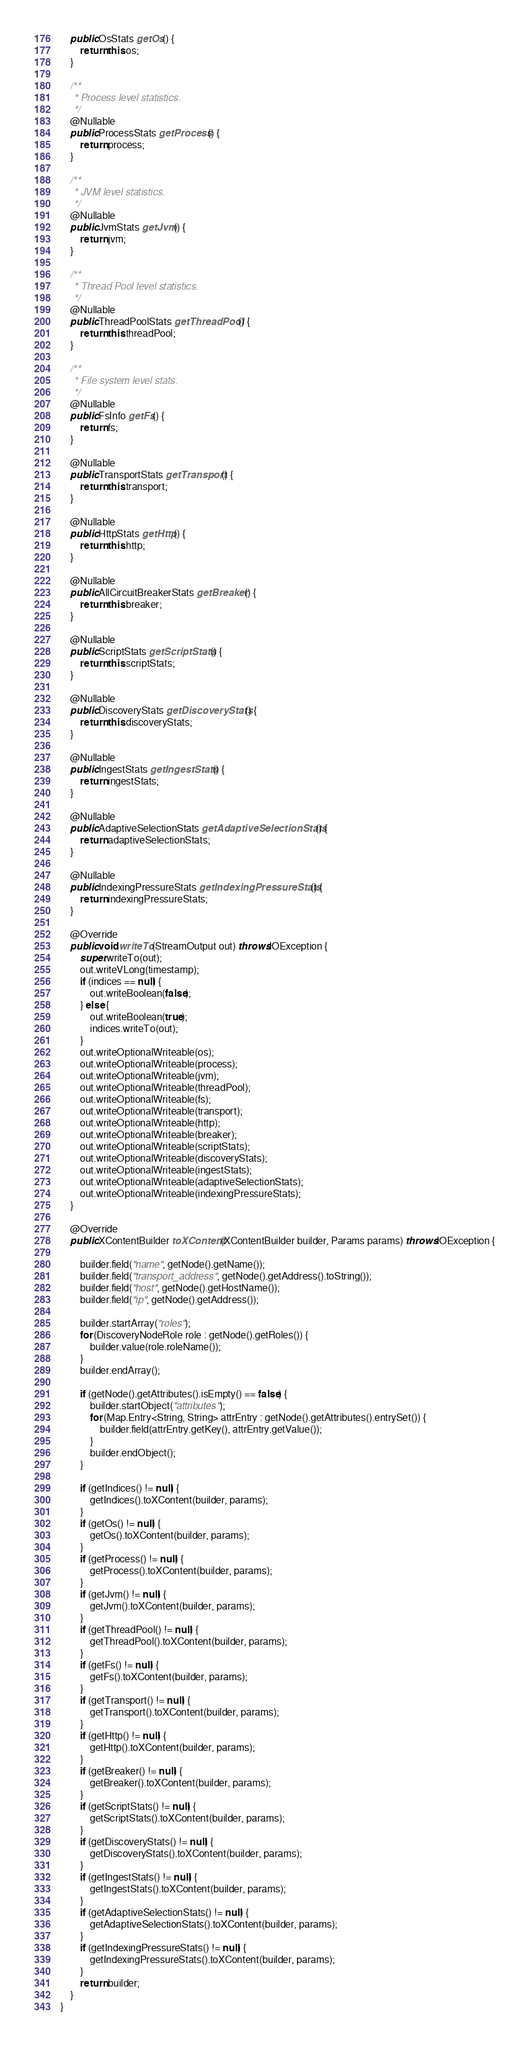<code> <loc_0><loc_0><loc_500><loc_500><_Java_>    public OsStats getOs() {
        return this.os;
    }

    /**
     * Process level statistics.
     */
    @Nullable
    public ProcessStats getProcess() {
        return process;
    }

    /**
     * JVM level statistics.
     */
    @Nullable
    public JvmStats getJvm() {
        return jvm;
    }

    /**
     * Thread Pool level statistics.
     */
    @Nullable
    public ThreadPoolStats getThreadPool() {
        return this.threadPool;
    }

    /**
     * File system level stats.
     */
    @Nullable
    public FsInfo getFs() {
        return fs;
    }

    @Nullable
    public TransportStats getTransport() {
        return this.transport;
    }

    @Nullable
    public HttpStats getHttp() {
        return this.http;
    }

    @Nullable
    public AllCircuitBreakerStats getBreaker() {
        return this.breaker;
    }

    @Nullable
    public ScriptStats getScriptStats() {
        return this.scriptStats;
    }

    @Nullable
    public DiscoveryStats getDiscoveryStats() {
        return this.discoveryStats;
    }

    @Nullable
    public IngestStats getIngestStats() {
        return ingestStats;
    }

    @Nullable
    public AdaptiveSelectionStats getAdaptiveSelectionStats() {
        return adaptiveSelectionStats;
    }

    @Nullable
    public IndexingPressureStats getIndexingPressureStats() {
        return indexingPressureStats;
    }

    @Override
    public void writeTo(StreamOutput out) throws IOException {
        super.writeTo(out);
        out.writeVLong(timestamp);
        if (indices == null) {
            out.writeBoolean(false);
        } else {
            out.writeBoolean(true);
            indices.writeTo(out);
        }
        out.writeOptionalWriteable(os);
        out.writeOptionalWriteable(process);
        out.writeOptionalWriteable(jvm);
        out.writeOptionalWriteable(threadPool);
        out.writeOptionalWriteable(fs);
        out.writeOptionalWriteable(transport);
        out.writeOptionalWriteable(http);
        out.writeOptionalWriteable(breaker);
        out.writeOptionalWriteable(scriptStats);
        out.writeOptionalWriteable(discoveryStats);
        out.writeOptionalWriteable(ingestStats);
        out.writeOptionalWriteable(adaptiveSelectionStats);
        out.writeOptionalWriteable(indexingPressureStats);
    }

    @Override
    public XContentBuilder toXContent(XContentBuilder builder, Params params) throws IOException {

        builder.field("name", getNode().getName());
        builder.field("transport_address", getNode().getAddress().toString());
        builder.field("host", getNode().getHostName());
        builder.field("ip", getNode().getAddress());

        builder.startArray("roles");
        for (DiscoveryNodeRole role : getNode().getRoles()) {
            builder.value(role.roleName());
        }
        builder.endArray();

        if (getNode().getAttributes().isEmpty() == false) {
            builder.startObject("attributes");
            for (Map.Entry<String, String> attrEntry : getNode().getAttributes().entrySet()) {
                builder.field(attrEntry.getKey(), attrEntry.getValue());
            }
            builder.endObject();
        }

        if (getIndices() != null) {
            getIndices().toXContent(builder, params);
        }
        if (getOs() != null) {
            getOs().toXContent(builder, params);
        }
        if (getProcess() != null) {
            getProcess().toXContent(builder, params);
        }
        if (getJvm() != null) {
            getJvm().toXContent(builder, params);
        }
        if (getThreadPool() != null) {
            getThreadPool().toXContent(builder, params);
        }
        if (getFs() != null) {
            getFs().toXContent(builder, params);
        }
        if (getTransport() != null) {
            getTransport().toXContent(builder, params);
        }
        if (getHttp() != null) {
            getHttp().toXContent(builder, params);
        }
        if (getBreaker() != null) {
            getBreaker().toXContent(builder, params);
        }
        if (getScriptStats() != null) {
            getScriptStats().toXContent(builder, params);
        }
        if (getDiscoveryStats() != null) {
            getDiscoveryStats().toXContent(builder, params);
        }
        if (getIngestStats() != null) {
            getIngestStats().toXContent(builder, params);
        }
        if (getAdaptiveSelectionStats() != null) {
            getAdaptiveSelectionStats().toXContent(builder, params);
        }
        if (getIndexingPressureStats() != null) {
            getIndexingPressureStats().toXContent(builder, params);
        }
        return builder;
    }
}
</code> 